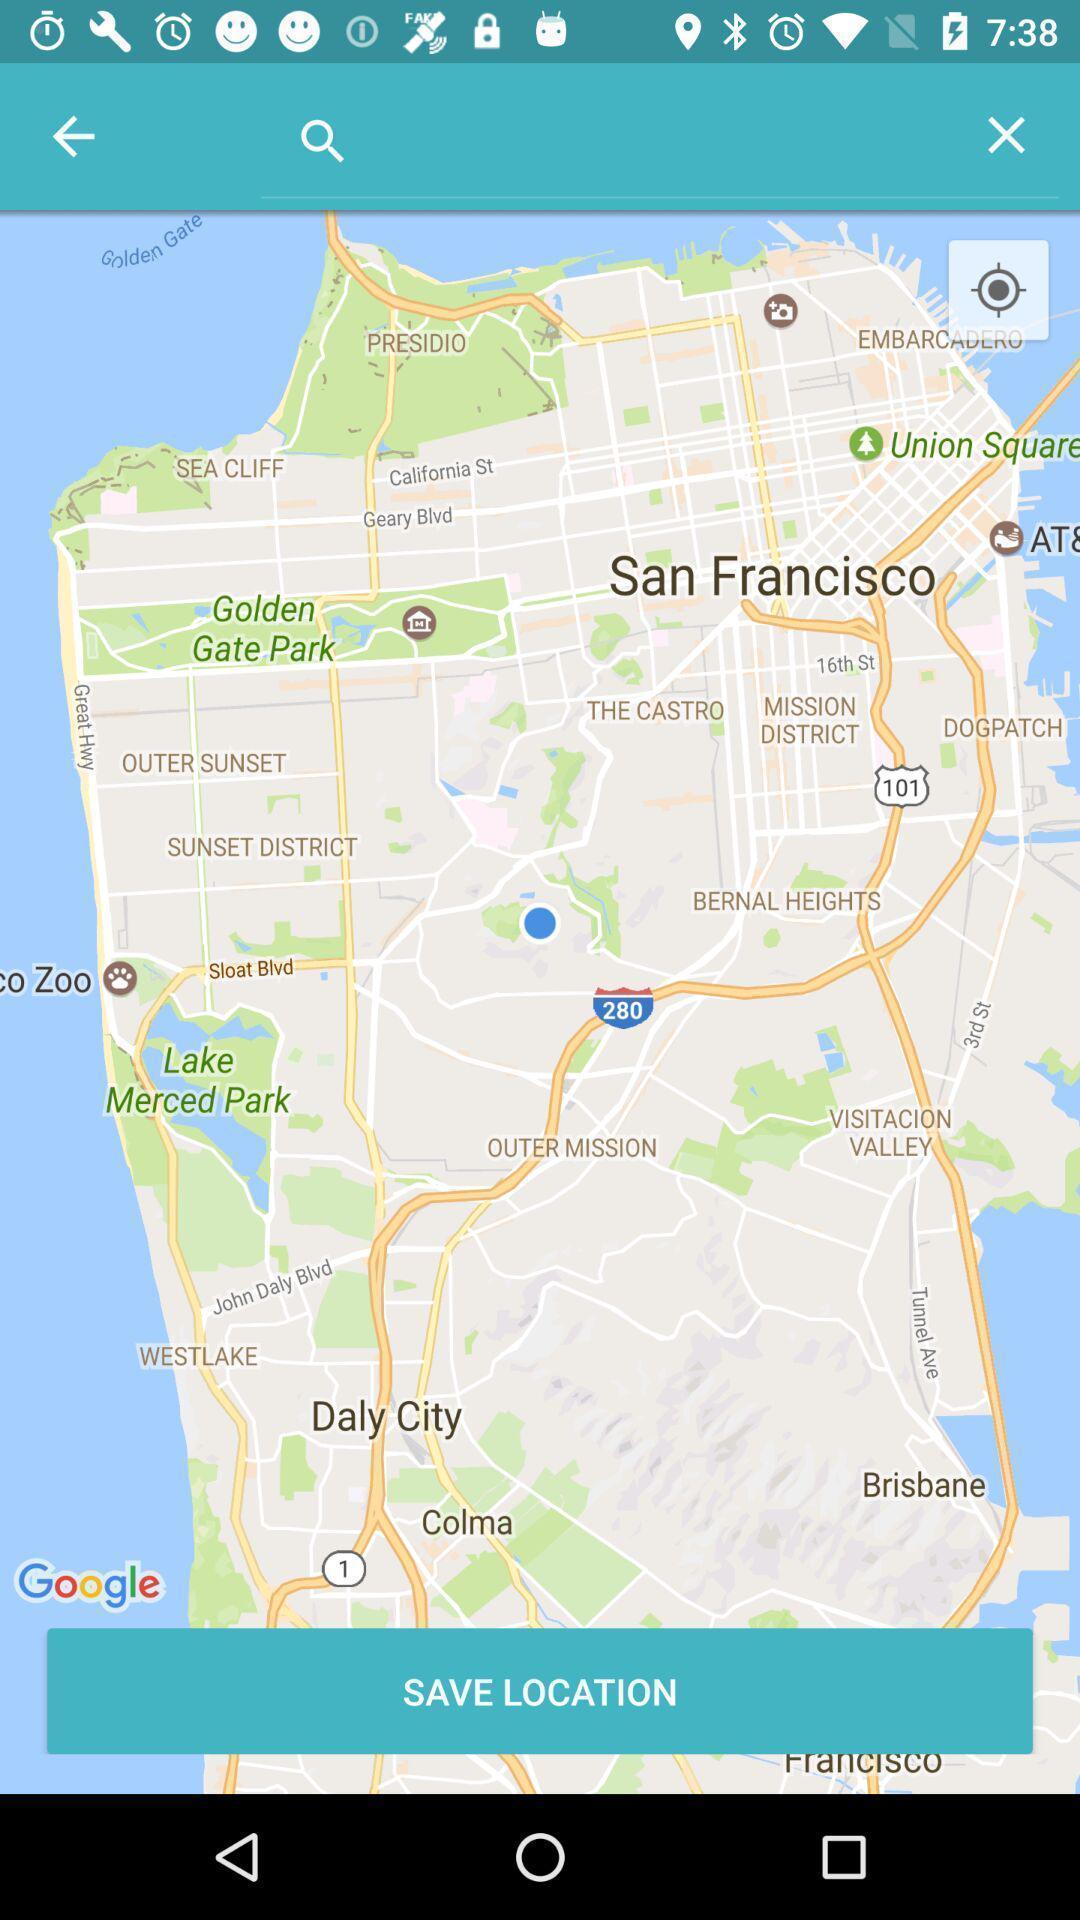Describe the visual elements of this screenshot. Screen shows to save location. 